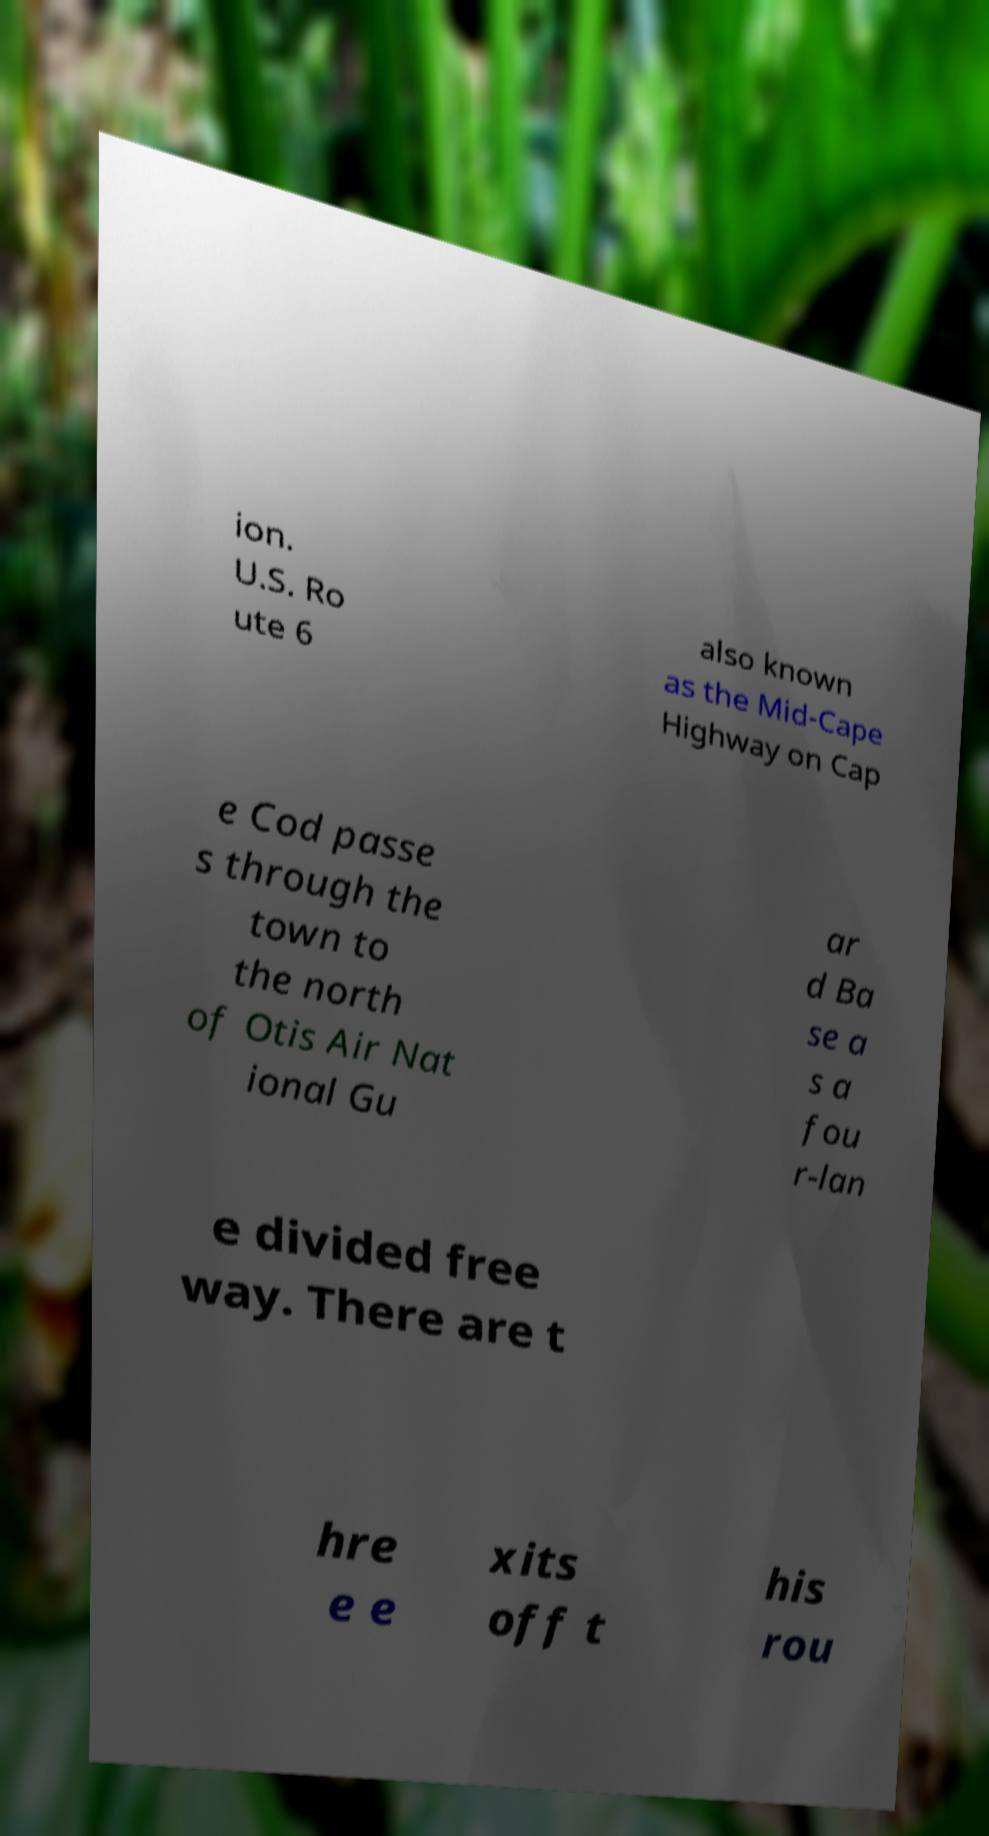There's text embedded in this image that I need extracted. Can you transcribe it verbatim? ion. U.S. Ro ute 6 also known as the Mid-Cape Highway on Cap e Cod passe s through the town to the north of Otis Air Nat ional Gu ar d Ba se a s a fou r-lan e divided free way. There are t hre e e xits off t his rou 